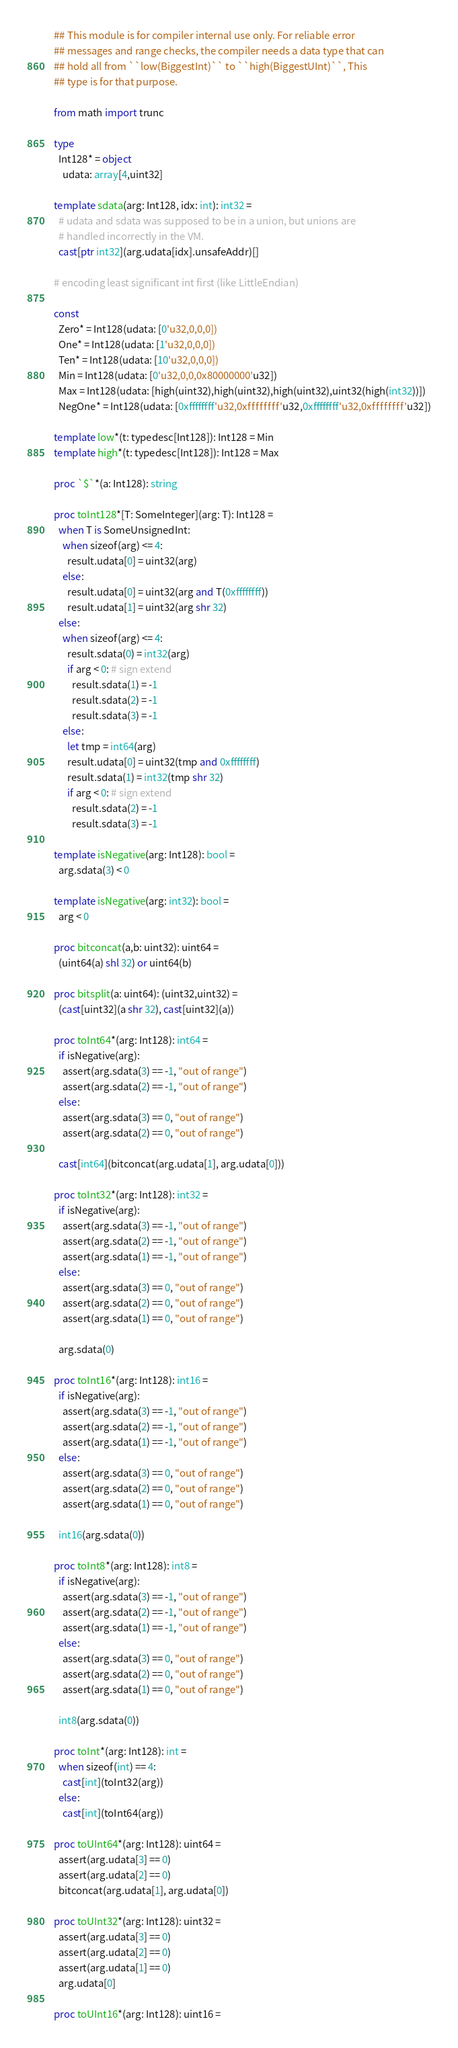Convert code to text. <code><loc_0><loc_0><loc_500><loc_500><_Nim_>## This module is for compiler internal use only. For reliable error
## messages and range checks, the compiler needs a data type that can
## hold all from ``low(BiggestInt)`` to ``high(BiggestUInt)``, This
## type is for that purpose.

from math import trunc

type
  Int128* = object
    udata: array[4,uint32]

template sdata(arg: Int128, idx: int): int32 =
  # udata and sdata was supposed to be in a union, but unions are
  # handled incorrectly in the VM.
  cast[ptr int32](arg.udata[idx].unsafeAddr)[]

# encoding least significant int first (like LittleEndian)

const
  Zero* = Int128(udata: [0'u32,0,0,0])
  One* = Int128(udata: [1'u32,0,0,0])
  Ten* = Int128(udata: [10'u32,0,0,0])
  Min = Int128(udata: [0'u32,0,0,0x80000000'u32])
  Max = Int128(udata: [high(uint32),high(uint32),high(uint32),uint32(high(int32))])
  NegOne* = Int128(udata: [0xffffffff'u32,0xffffffff'u32,0xffffffff'u32,0xffffffff'u32])

template low*(t: typedesc[Int128]): Int128 = Min
template high*(t: typedesc[Int128]): Int128 = Max

proc `$`*(a: Int128): string

proc toInt128*[T: SomeInteger](arg: T): Int128 =
  when T is SomeUnsignedInt:
    when sizeof(arg) <= 4:
      result.udata[0] = uint32(arg)
    else:
      result.udata[0] = uint32(arg and T(0xffffffff))
      result.udata[1] = uint32(arg shr 32)
  else:
    when sizeof(arg) <= 4:
      result.sdata(0) = int32(arg)
      if arg < 0: # sign extend
        result.sdata(1) = -1
        result.sdata(2) = -1
        result.sdata(3) = -1
    else:
      let tmp = int64(arg)
      result.udata[0] = uint32(tmp and 0xffffffff)
      result.sdata(1) = int32(tmp shr 32)
      if arg < 0: # sign extend
        result.sdata(2) = -1
        result.sdata(3) = -1

template isNegative(arg: Int128): bool =
  arg.sdata(3) < 0

template isNegative(arg: int32): bool =
  arg < 0

proc bitconcat(a,b: uint32): uint64 =
  (uint64(a) shl 32) or uint64(b)

proc bitsplit(a: uint64): (uint32,uint32) =
  (cast[uint32](a shr 32), cast[uint32](a))

proc toInt64*(arg: Int128): int64 =
  if isNegative(arg):
    assert(arg.sdata(3) == -1, "out of range")
    assert(arg.sdata(2) == -1, "out of range")
  else:
    assert(arg.sdata(3) == 0, "out of range")
    assert(arg.sdata(2) == 0, "out of range")

  cast[int64](bitconcat(arg.udata[1], arg.udata[0]))

proc toInt32*(arg: Int128): int32 =
  if isNegative(arg):
    assert(arg.sdata(3) == -1, "out of range")
    assert(arg.sdata(2) == -1, "out of range")
    assert(arg.sdata(1) == -1, "out of range")
  else:
    assert(arg.sdata(3) == 0, "out of range")
    assert(arg.sdata(2) == 0, "out of range")
    assert(arg.sdata(1) == 0, "out of range")

  arg.sdata(0)

proc toInt16*(arg: Int128): int16 =
  if isNegative(arg):
    assert(arg.sdata(3) == -1, "out of range")
    assert(arg.sdata(2) == -1, "out of range")
    assert(arg.sdata(1) == -1, "out of range")
  else:
    assert(arg.sdata(3) == 0, "out of range")
    assert(arg.sdata(2) == 0, "out of range")
    assert(arg.sdata(1) == 0, "out of range")

  int16(arg.sdata(0))

proc toInt8*(arg: Int128): int8 =
  if isNegative(arg):
    assert(arg.sdata(3) == -1, "out of range")
    assert(arg.sdata(2) == -1, "out of range")
    assert(arg.sdata(1) == -1, "out of range")
  else:
    assert(arg.sdata(3) == 0, "out of range")
    assert(arg.sdata(2) == 0, "out of range")
    assert(arg.sdata(1) == 0, "out of range")

  int8(arg.sdata(0))

proc toInt*(arg: Int128): int =
  when sizeof(int) == 4:
    cast[int](toInt32(arg))
  else:
    cast[int](toInt64(arg))

proc toUInt64*(arg: Int128): uint64 =
  assert(arg.udata[3] == 0)
  assert(arg.udata[2] == 0)
  bitconcat(arg.udata[1], arg.udata[0])

proc toUInt32*(arg: Int128): uint32 =
  assert(arg.udata[3] == 0)
  assert(arg.udata[2] == 0)
  assert(arg.udata[1] == 0)
  arg.udata[0]

proc toUInt16*(arg: Int128): uint16 =</code> 